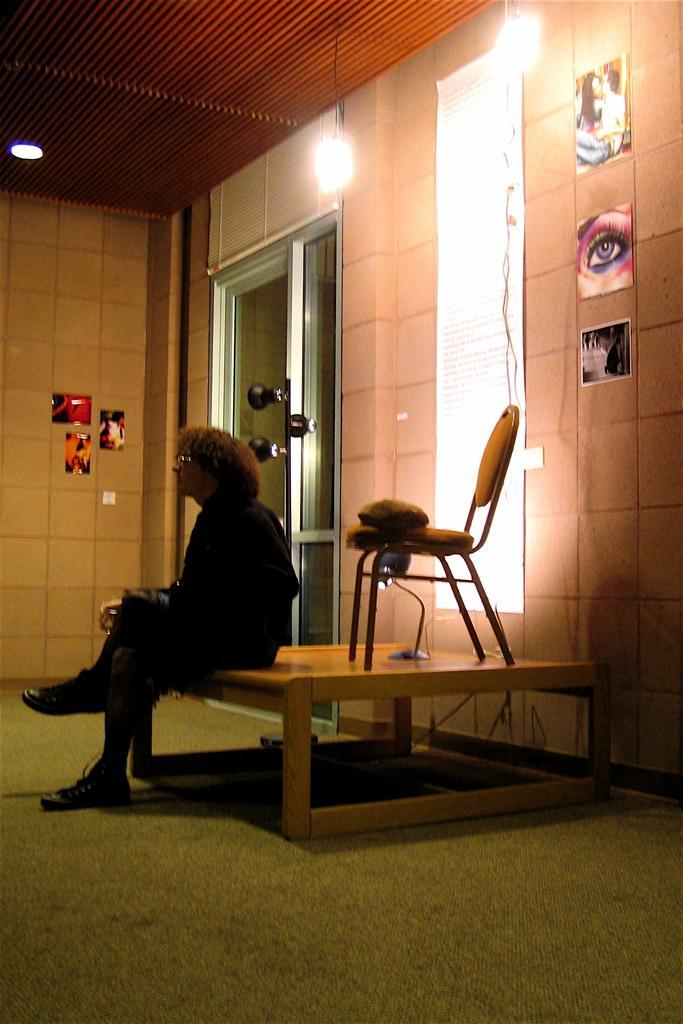How would you summarize this image in a sentence or two? This image describes a woman is seated on the table, and we can see a chair a light are on it, behind to her we can see wall photos and lights. 